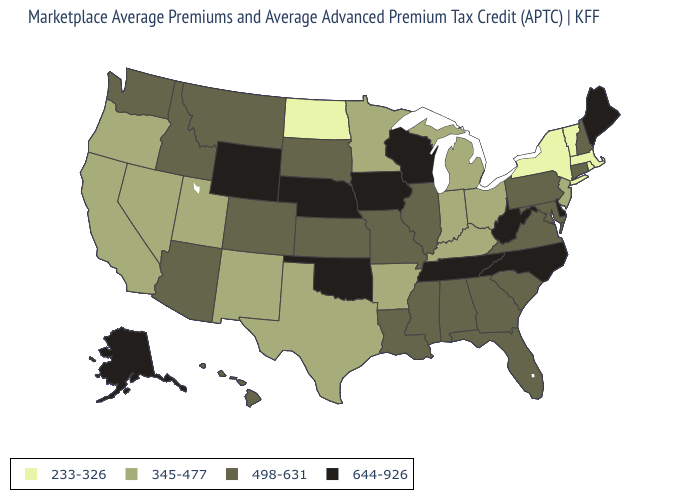What is the lowest value in states that border Florida?
Be succinct. 498-631. Does the map have missing data?
Be succinct. No. What is the value of North Carolina?
Short answer required. 644-926. Name the states that have a value in the range 644-926?
Short answer required. Alaska, Delaware, Iowa, Maine, Nebraska, North Carolina, Oklahoma, Tennessee, West Virginia, Wisconsin, Wyoming. Does New York have the lowest value in the USA?
Keep it brief. Yes. What is the value of Maryland?
Quick response, please. 498-631. Name the states that have a value in the range 233-326?
Answer briefly. Massachusetts, New York, North Dakota, Rhode Island, Vermont. Which states hav the highest value in the West?
Give a very brief answer. Alaska, Wyoming. Name the states that have a value in the range 345-477?
Short answer required. Arkansas, California, Indiana, Kentucky, Michigan, Minnesota, Nevada, New Jersey, New Mexico, Ohio, Oregon, Texas, Utah. Which states have the lowest value in the USA?
Write a very short answer. Massachusetts, New York, North Dakota, Rhode Island, Vermont. Does Kentucky have the highest value in the South?
Be succinct. No. Name the states that have a value in the range 644-926?
Quick response, please. Alaska, Delaware, Iowa, Maine, Nebraska, North Carolina, Oklahoma, Tennessee, West Virginia, Wisconsin, Wyoming. Name the states that have a value in the range 345-477?
Concise answer only. Arkansas, California, Indiana, Kentucky, Michigan, Minnesota, Nevada, New Jersey, New Mexico, Ohio, Oregon, Texas, Utah. Does the map have missing data?
Quick response, please. No. Does Oregon have the same value as Colorado?
Concise answer only. No. 